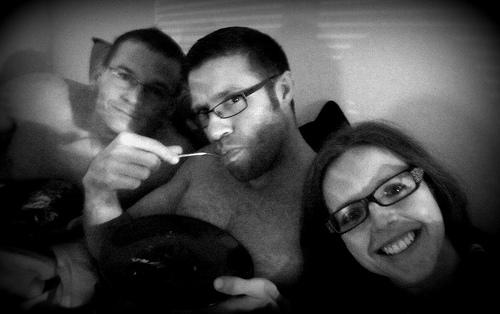Question: what do all three wear on their face?
Choices:
A. A mask.
B. Lipstick.
C. Eyeshadow.
D. Glasses.
Answer with the letter. Answer: D Question: what is the man in the middle doing?
Choices:
A. Eating.
B. Dancing.
C. Shouting.
D. Singing.
Answer with the letter. Answer: A Question: how many people have plates?
Choices:
A. One.
B. Three.
C. Four.
D. Two.
Answer with the letter. Answer: D Question: how many people are smiling big?
Choices:
A. Two.
B. One.
C. None.
D. Four.
Answer with the letter. Answer: B Question: how many people are in this picture?
Choices:
A. One.
B. Two.
C. Three.
D. Four.
Answer with the letter. Answer: C Question: who is on the right?
Choices:
A. A woman.
B. A man.
C. A baby.
D. A dog.
Answer with the letter. Answer: A Question: what filter is used on this picture?
Choices:
A. Mono.
B. Tonal.
C. Chrome.
D. Black and white.
Answer with the letter. Answer: D Question: where is the middle man's fork?
Choices:
A. In his hand.
B. In his mouth.
C. On his plate.
D. On the table.
Answer with the letter. Answer: B 